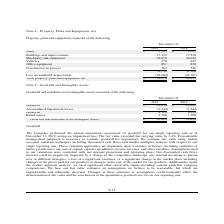According to Lifeway Foods's financial document, By how much did the fair value exceed the carrying value by? According to the financial document, 2.4%. The relevant text states: "oss. The fair value exceeded the carrying value by 2.4%. Considerable management judgment is necessary to evaluate goodwill for impairment. We estimate fai..." Also, What does the company use to estimate fair value? Widely accepted valuation techniques including discounted cash flows and market multiples analysis with respect to our single reporting unit. The document states: "will for impairment. We estimate fair value using widely accepted valuation techniques including discounted cash flows and market multiples analysis w..." Also, What is the value of brand names as of December 31, 2019? According to the financial document, 3,700. The relevant text states: "Brand names 3,700 3,700..." Also, can you calculate: What is the change in the value of brand names between 2018 and 2019? I cannot find a specific answer to this question in the financial document. Also, can you calculate: What is the average goodwill and indefinite lived intangible assets for 2018 and 2019? To answer this question, I need to perform calculations using the financial data. The calculation is: (12,824+12,824)/2, which equals 12824. This is based on the information: "Goodwill and indefinite lived intangible assets $ 12,824 $ 12,824..." Also, can you calculate: What is the percentage constitution of brand names among the total goodwill and indefinite lived intangible assets in 2019? Based on the calculation: 3,700/12,824, the result is 28.85 (percentage). This is based on the information: "Goodwill and indefinite lived intangible assets $ 12,824 $ 12,824 Brand names 3,700 3,700..." The key data points involved are: 12,824, 3,700. 